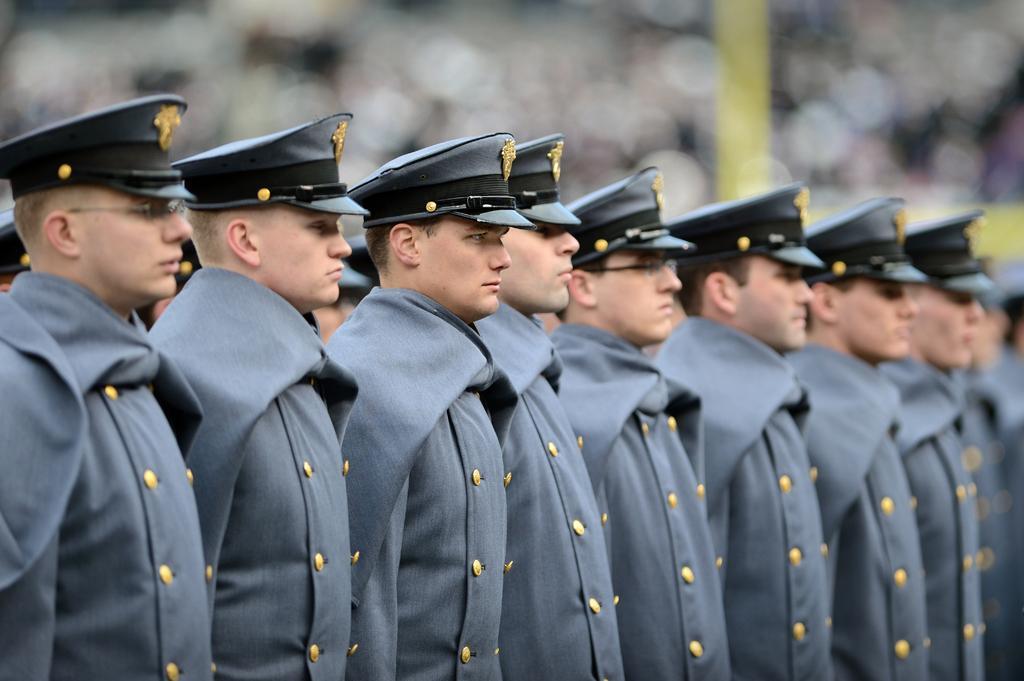In one or two sentences, can you explain what this image depicts? In this image we can see some people standing and wearing the uniform and caps and in the background the image is blurred. 